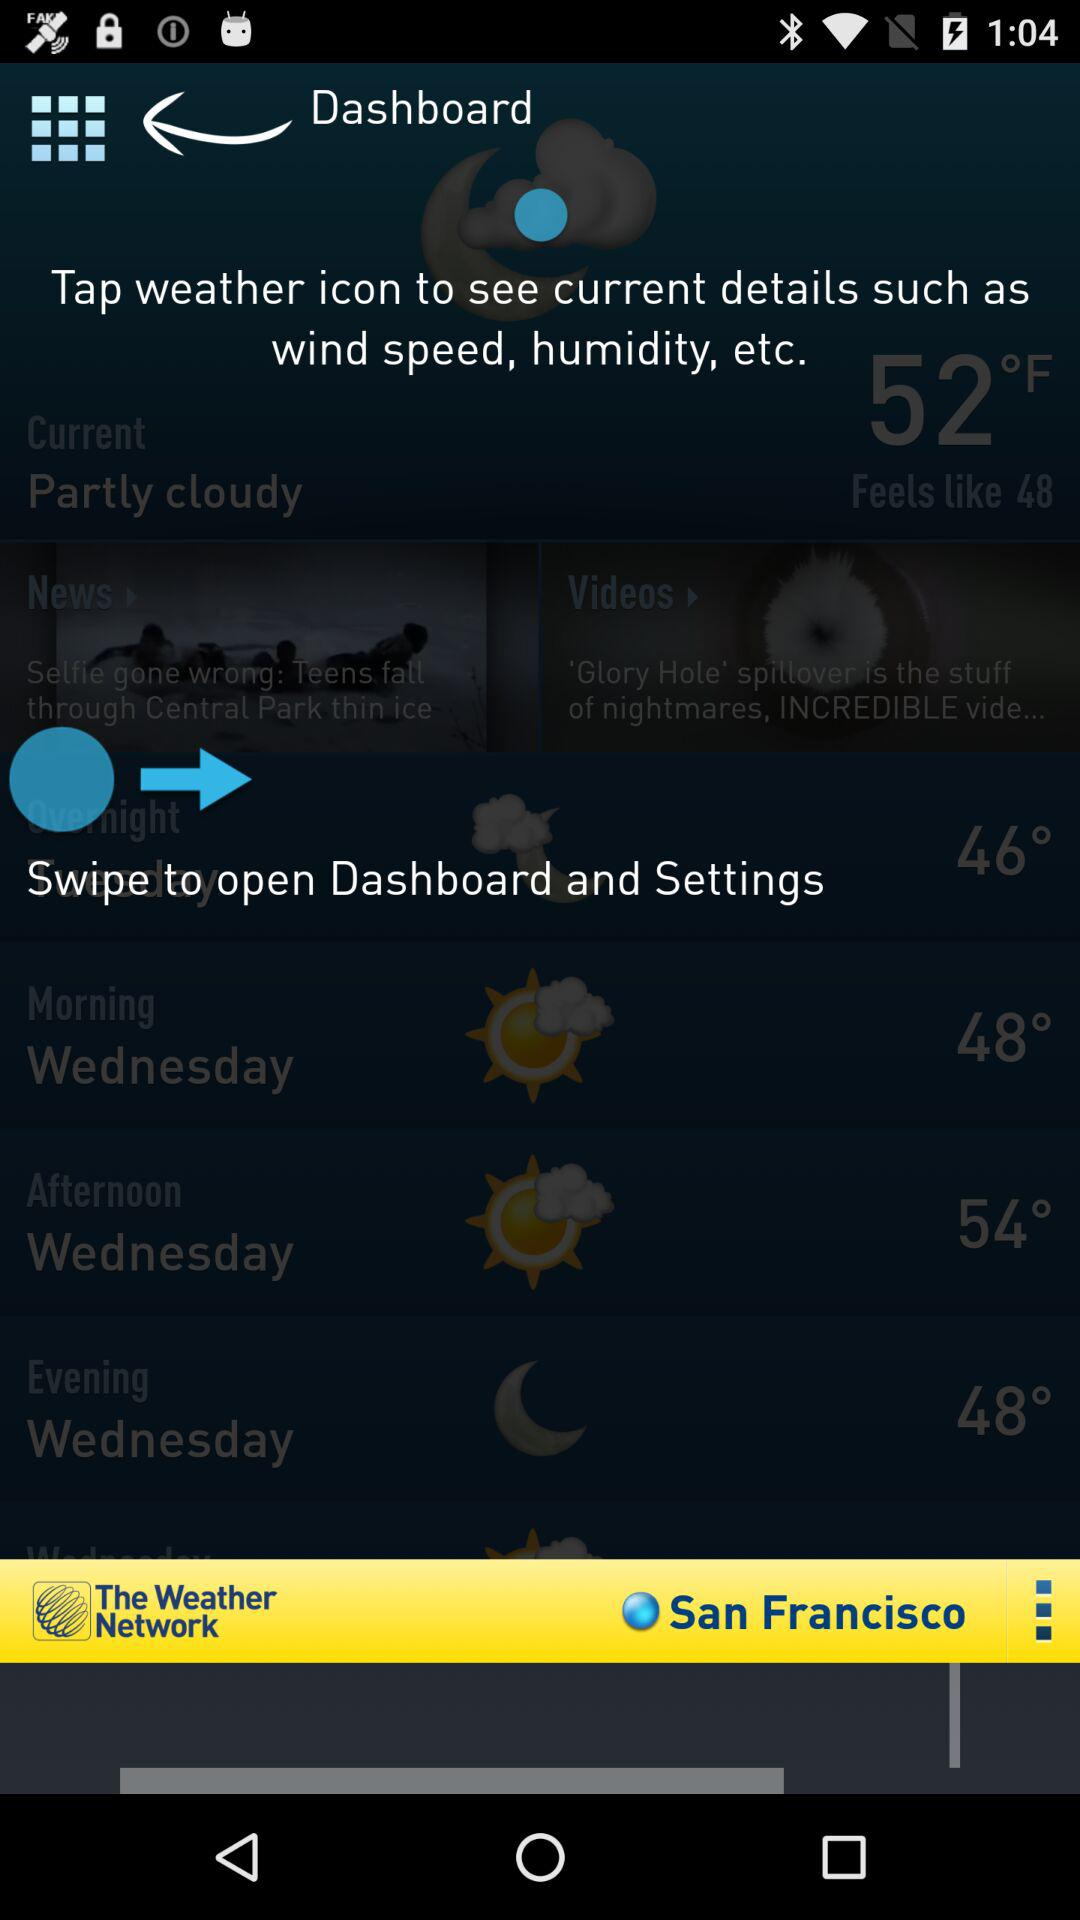How many more degrees Fahrenheit is the current temperature than the feels like temperature?
Answer the question using a single word or phrase. 4 